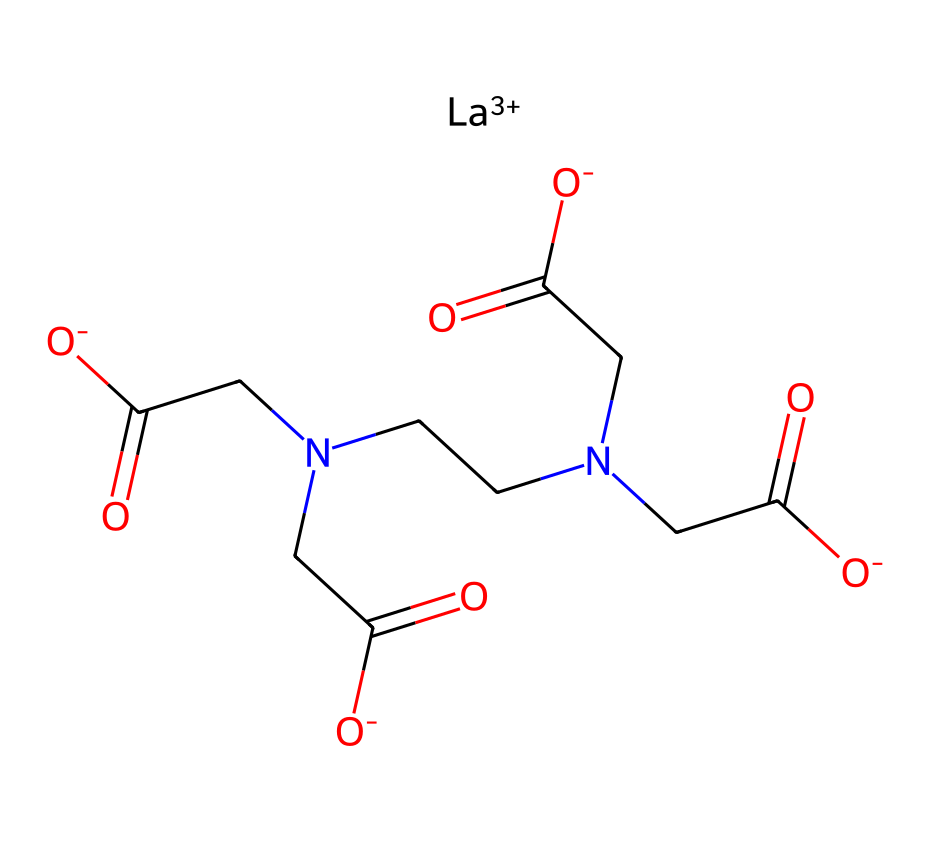What is the central metal atom in this coordination compound? The chemical structure includes a lanthanide ion, represented as [La+3], indicating that the central metal atom is lanthanum.
Answer: lanthanum How many carboxylate groups are present in this structure? Analyzing the structure shows four instances of the carboxylate group, indicated by the presence of =O and [O-] adjacent to carbon atoms.
Answer: four What type of ligands are coordinating with the lanthanide ion? The structure includes amine groups (from the CN part) and carboxylate groups (the O=C([O-]) parts) as ligands that are coordinating to the lanthanide ion.
Answer: amine and carboxylate What is the overall charge of this coordination complex? The coordination complex can be assessed by calculating the charges of the components: La has a +3 charge, and there are four carboxylate groups, each contributing a -1 charge, resulting in a net charge of -1.
Answer: negative one How many nitrogen atoms are present in this chemical structure? By examining the structure, there are three nitrogen atoms present coming from the CN components in two places and one connecting to the carboxylate structure.
Answer: three What is the likely application of this lanthanide coordination compound in photography? The compound's structure suggests it is a chelating agent for metal ions, which enhances the performance of high-speed films, capturing rapid moments.
Answer: photography 